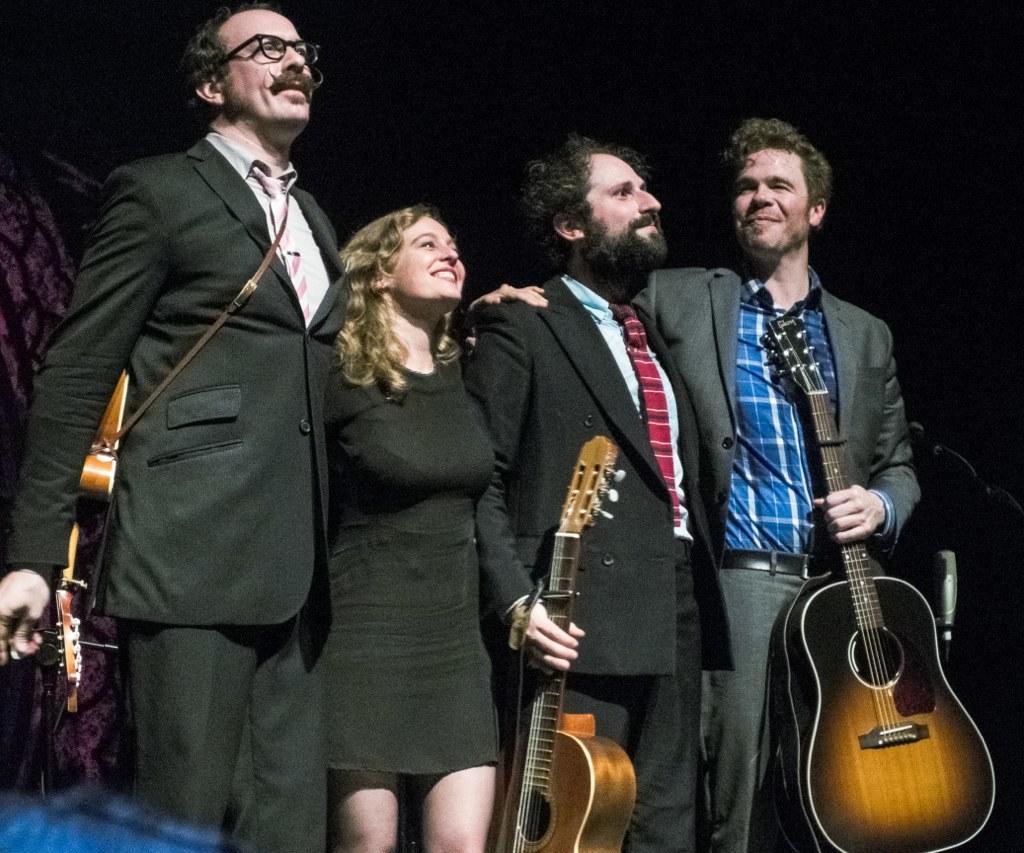Describe this image in one or two sentences. In this picture we can see four persons holding guitars in their hand and smiling and in middle she is woman and remaining are men. 